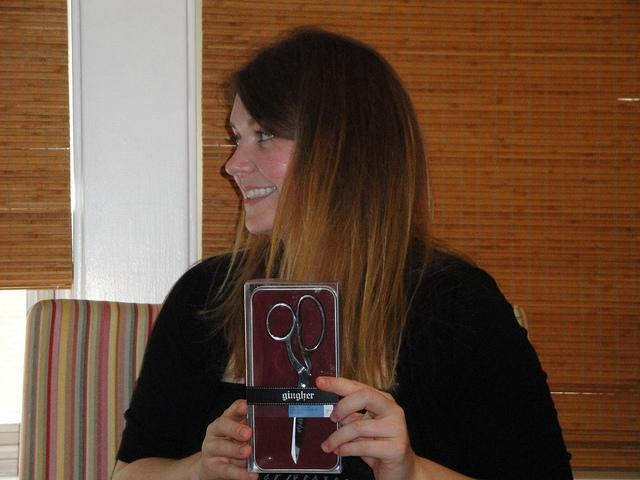What is the design of the chair? striped 